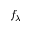Convert formula to latex. <formula><loc_0><loc_0><loc_500><loc_500>f _ { \lambda }</formula> 